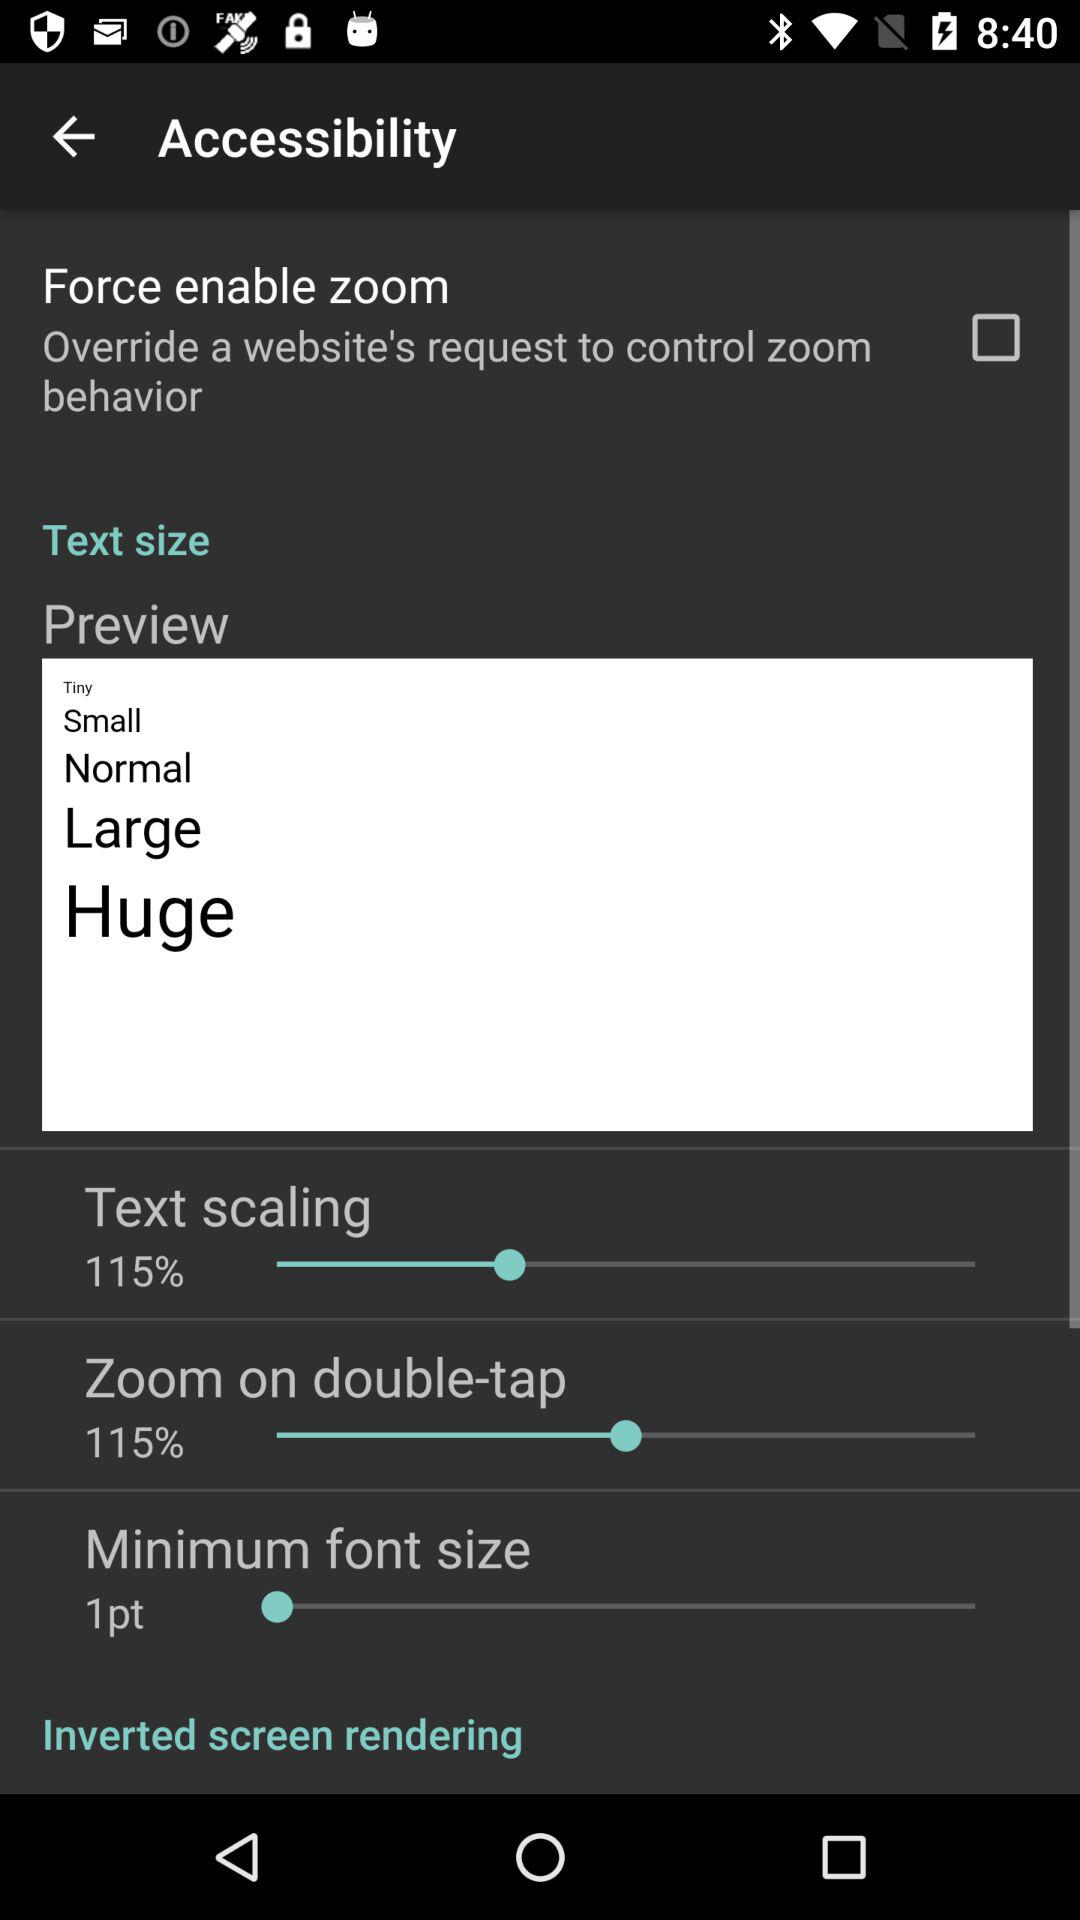What is the percentage of text scaling? The percentage of text scaling is 115. 